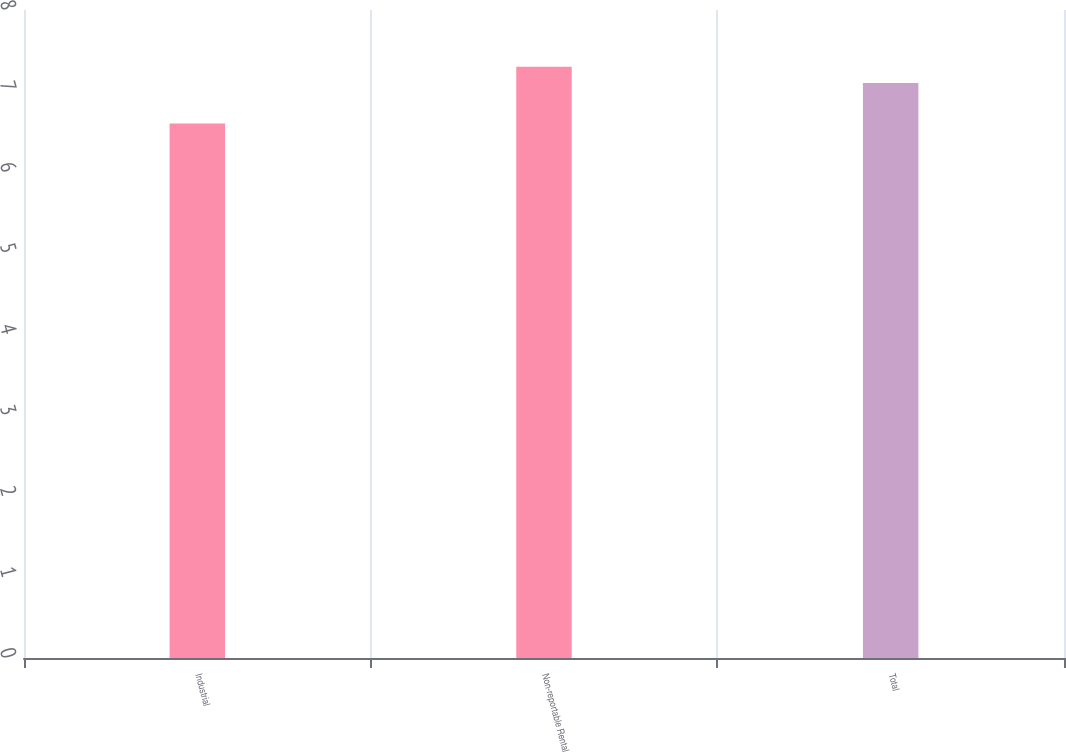<chart> <loc_0><loc_0><loc_500><loc_500><bar_chart><fcel>Industrial<fcel>Non-reportable Rental<fcel>Total<nl><fcel>6.6<fcel>7.3<fcel>7.1<nl></chart> 